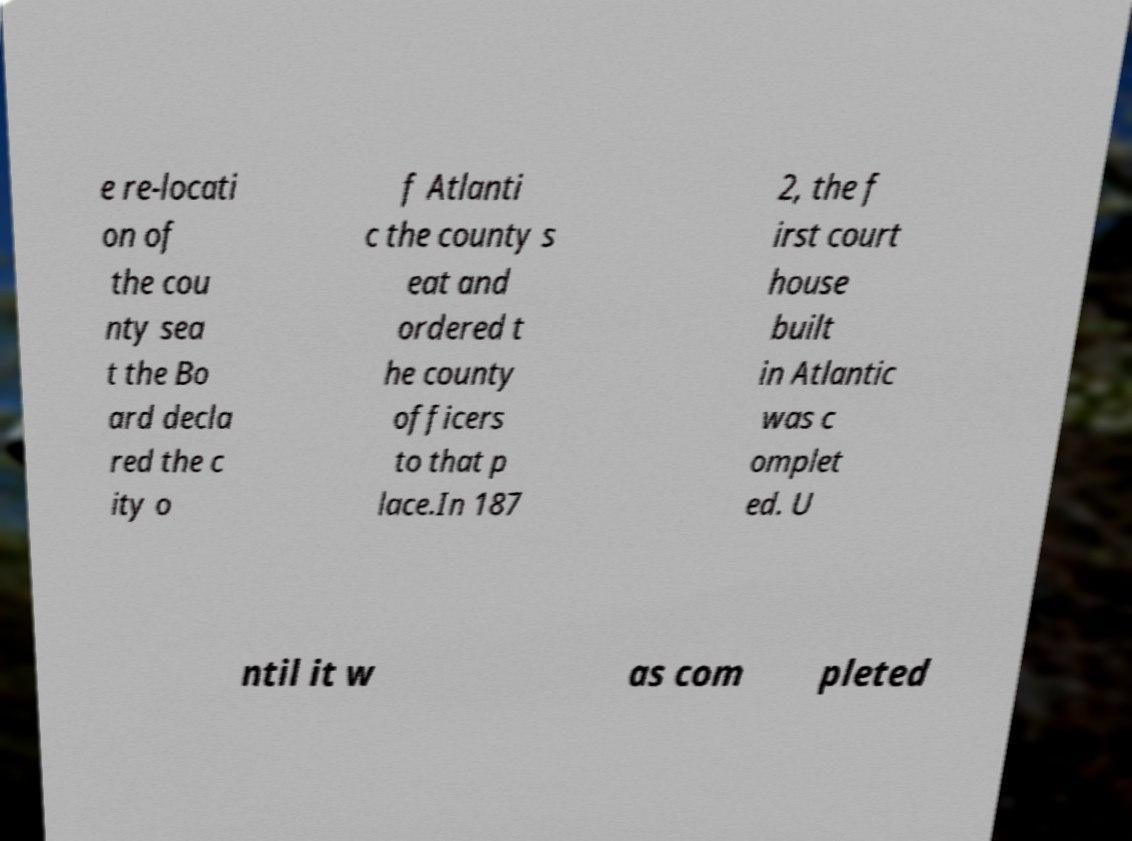What messages or text are displayed in this image? I need them in a readable, typed format. e re-locati on of the cou nty sea t the Bo ard decla red the c ity o f Atlanti c the county s eat and ordered t he county officers to that p lace.In 187 2, the f irst court house built in Atlantic was c omplet ed. U ntil it w as com pleted 